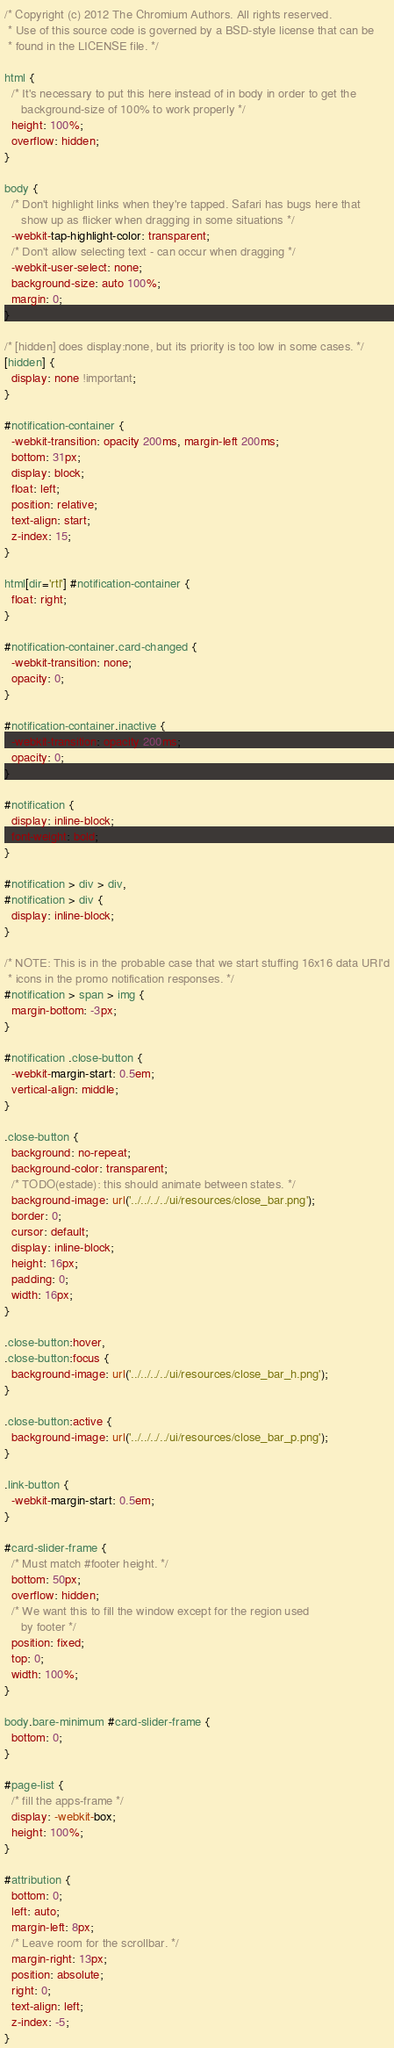Convert code to text. <code><loc_0><loc_0><loc_500><loc_500><_CSS_>/* Copyright (c) 2012 The Chromium Authors. All rights reserved.
 * Use of this source code is governed by a BSD-style license that can be
 * found in the LICENSE file. */

html {
  /* It's necessary to put this here instead of in body in order to get the
     background-size of 100% to work properly */
  height: 100%;
  overflow: hidden;
}

body {
  /* Don't highlight links when they're tapped. Safari has bugs here that
     show up as flicker when dragging in some situations */
  -webkit-tap-highlight-color: transparent;
  /* Don't allow selecting text - can occur when dragging */
  -webkit-user-select: none;
  background-size: auto 100%;
  margin: 0;
}

/* [hidden] does display:none, but its priority is too low in some cases. */
[hidden] {
  display: none !important;
}

#notification-container {
  -webkit-transition: opacity 200ms, margin-left 200ms;
  bottom: 31px;
  display: block;
  float: left;
  position: relative;
  text-align: start;
  z-index: 15;
}

html[dir='rtl'] #notification-container {
  float: right;
}

#notification-container.card-changed {
  -webkit-transition: none;
  opacity: 0;
}

#notification-container.inactive {
  -webkit-transition: opacity 200ms;
  opacity: 0;
}

#notification {
  display: inline-block;
  font-weight: bold;
}

#notification > div > div,
#notification > div {
  display: inline-block;
}

/* NOTE: This is in the probable case that we start stuffing 16x16 data URI'd
 * icons in the promo notification responses. */
#notification > span > img {
  margin-bottom: -3px;
}

#notification .close-button {
  -webkit-margin-start: 0.5em;
  vertical-align: middle;
}

.close-button {
  background: no-repeat;
  background-color: transparent;
  /* TODO(estade): this should animate between states. */
  background-image: url('../../../../ui/resources/close_bar.png');
  border: 0;
  cursor: default;
  display: inline-block;
  height: 16px;
  padding: 0;
  width: 16px;
}

.close-button:hover,
.close-button:focus {
  background-image: url('../../../../ui/resources/close_bar_h.png');
}

.close-button:active {
  background-image: url('../../../../ui/resources/close_bar_p.png');
}

.link-button {
  -webkit-margin-start: 0.5em;
}

#card-slider-frame {
  /* Must match #footer height. */
  bottom: 50px;
  overflow: hidden;
  /* We want this to fill the window except for the region used
     by footer */
  position: fixed;
  top: 0;
  width: 100%;
}

body.bare-minimum #card-slider-frame {
  bottom: 0;
}

#page-list {
  /* fill the apps-frame */
  display: -webkit-box;
  height: 100%;
}

#attribution {
  bottom: 0;
  left: auto;
  margin-left: 8px;
  /* Leave room for the scrollbar. */
  margin-right: 13px;
  position: absolute;
  right: 0;
  text-align: left;
  z-index: -5;
}
</code> 